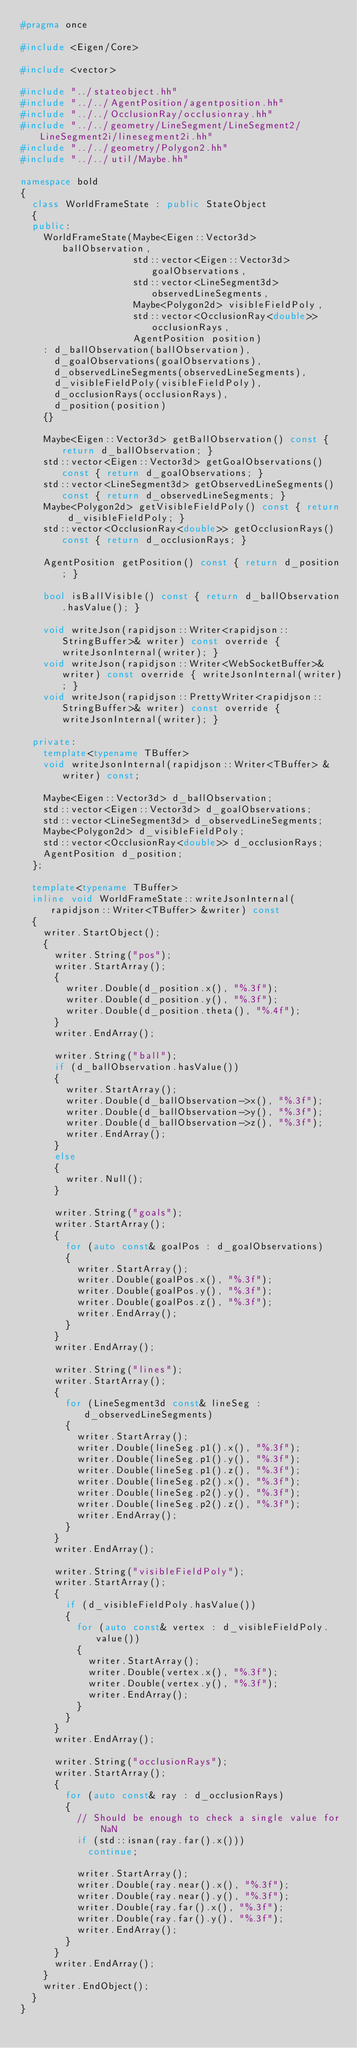Convert code to text. <code><loc_0><loc_0><loc_500><loc_500><_C++_>#pragma once

#include <Eigen/Core>

#include <vector>

#include "../stateobject.hh"
#include "../../AgentPosition/agentposition.hh"
#include "../../OcclusionRay/occlusionray.hh"
#include "../../geometry/LineSegment/LineSegment2/LineSegment2i/linesegment2i.hh"
#include "../../geometry/Polygon2.hh"
#include "../../util/Maybe.hh"

namespace bold
{
  class WorldFrameState : public StateObject
  {
  public:
    WorldFrameState(Maybe<Eigen::Vector3d> ballObservation,
                    std::vector<Eigen::Vector3d> goalObservations,
                    std::vector<LineSegment3d> observedLineSegments,
                    Maybe<Polygon2d> visibleFieldPoly,
                    std::vector<OcclusionRay<double>> occlusionRays,
                    AgentPosition position)
    : d_ballObservation(ballObservation),
      d_goalObservations(goalObservations),
      d_observedLineSegments(observedLineSegments),
      d_visibleFieldPoly(visibleFieldPoly),
      d_occlusionRays(occlusionRays),
      d_position(position)
    {}

    Maybe<Eigen::Vector3d> getBallObservation() const { return d_ballObservation; }
    std::vector<Eigen::Vector3d> getGoalObservations() const { return d_goalObservations; }
    std::vector<LineSegment3d> getObservedLineSegments() const { return d_observedLineSegments; }
    Maybe<Polygon2d> getVisibleFieldPoly() const { return d_visibleFieldPoly; }
    std::vector<OcclusionRay<double>> getOcclusionRays() const { return d_occlusionRays; }

    AgentPosition getPosition() const { return d_position; }

    bool isBallVisible() const { return d_ballObservation.hasValue(); }

    void writeJson(rapidjson::Writer<rapidjson::StringBuffer>& writer) const override { writeJsonInternal(writer); }
    void writeJson(rapidjson::Writer<WebSocketBuffer>& writer) const override { writeJsonInternal(writer); }
    void writeJson(rapidjson::PrettyWriter<rapidjson::StringBuffer>& writer) const override { writeJsonInternal(writer); }

  private:
    template<typename TBuffer>
    void writeJsonInternal(rapidjson::Writer<TBuffer> &writer) const;

    Maybe<Eigen::Vector3d> d_ballObservation;
    std::vector<Eigen::Vector3d> d_goalObservations;
    std::vector<LineSegment3d> d_observedLineSegments;
    Maybe<Polygon2d> d_visibleFieldPoly;
    std::vector<OcclusionRay<double>> d_occlusionRays;
    AgentPosition d_position;
  };

  template<typename TBuffer>
  inline void WorldFrameState::writeJsonInternal(rapidjson::Writer<TBuffer> &writer) const
  {
    writer.StartObject();
    {
      writer.String("pos");
      writer.StartArray();
      {
        writer.Double(d_position.x(), "%.3f");
        writer.Double(d_position.y(), "%.3f");
        writer.Double(d_position.theta(), "%.4f");
      }
      writer.EndArray();

      writer.String("ball");
      if (d_ballObservation.hasValue())
      {
        writer.StartArray();
        writer.Double(d_ballObservation->x(), "%.3f");
        writer.Double(d_ballObservation->y(), "%.3f");
        writer.Double(d_ballObservation->z(), "%.3f");
        writer.EndArray();
      }
      else
      {
        writer.Null();
      }

      writer.String("goals");
      writer.StartArray();
      {
        for (auto const& goalPos : d_goalObservations)
        {
          writer.StartArray();
          writer.Double(goalPos.x(), "%.3f");
          writer.Double(goalPos.y(), "%.3f");
          writer.Double(goalPos.z(), "%.3f");
          writer.EndArray();
        }
      }
      writer.EndArray();

      writer.String("lines");
      writer.StartArray();
      {
        for (LineSegment3d const& lineSeg : d_observedLineSegments)
        {
          writer.StartArray();
          writer.Double(lineSeg.p1().x(), "%.3f");
          writer.Double(lineSeg.p1().y(), "%.3f");
          writer.Double(lineSeg.p1().z(), "%.3f");
          writer.Double(lineSeg.p2().x(), "%.3f");
          writer.Double(lineSeg.p2().y(), "%.3f");
          writer.Double(lineSeg.p2().z(), "%.3f");
          writer.EndArray();
        }
      }
      writer.EndArray();

      writer.String("visibleFieldPoly");
      writer.StartArray();
      {
        if (d_visibleFieldPoly.hasValue())
        {
          for (auto const& vertex : d_visibleFieldPoly.value())
          {
            writer.StartArray();
            writer.Double(vertex.x(), "%.3f");
            writer.Double(vertex.y(), "%.3f");
            writer.EndArray();
          }
        }
      }
      writer.EndArray();

      writer.String("occlusionRays");
      writer.StartArray();
      {
        for (auto const& ray : d_occlusionRays)
        {
          // Should be enough to check a single value for NaN
          if (std::isnan(ray.far().x()))
            continue;

          writer.StartArray();
          writer.Double(ray.near().x(), "%.3f");
          writer.Double(ray.near().y(), "%.3f");
          writer.Double(ray.far().x(), "%.3f");
          writer.Double(ray.far().y(), "%.3f");
          writer.EndArray();
        }
      }
      writer.EndArray();
    }
    writer.EndObject();
  }
}
</code> 